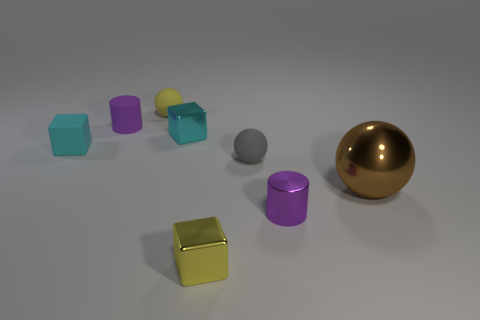Is there anything else that is the same size as the brown metallic sphere?
Offer a terse response. No. There is a small cylinder to the left of the purple cylinder that is right of the yellow object behind the metal sphere; what is it made of?
Offer a terse response. Rubber. Does the shiny object that is on the right side of the small metallic cylinder have the same shape as the small metallic object that is right of the tiny yellow metal block?
Ensure brevity in your answer.  No. How many other things are there of the same material as the brown ball?
Ensure brevity in your answer.  3. Does the purple cylinder in front of the tiny gray object have the same material as the tiny purple thing that is behind the big metallic object?
Make the answer very short. No. There is a cyan thing that is the same material as the gray thing; what is its shape?
Ensure brevity in your answer.  Cube. Are there any other things that are the same color as the matte cube?
Give a very brief answer. Yes. What number of small yellow rubber balls are there?
Keep it short and to the point. 1. There is a tiny matte object that is right of the tiny rubber cylinder and in front of the small yellow matte ball; what is its shape?
Offer a terse response. Sphere. There is a tiny purple thing that is on the left side of the rubber ball that is behind the cyan thing behind the tiny rubber cube; what shape is it?
Keep it short and to the point. Cylinder. 